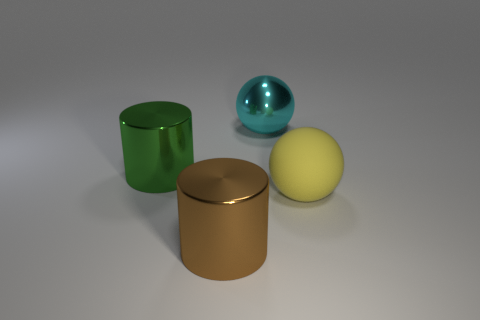Add 2 big spheres. How many objects exist? 6 Subtract all green metallic cylinders. Subtract all large gray cylinders. How many objects are left? 3 Add 2 rubber objects. How many rubber objects are left? 3 Add 4 large brown things. How many large brown things exist? 5 Subtract 0 red cubes. How many objects are left? 4 